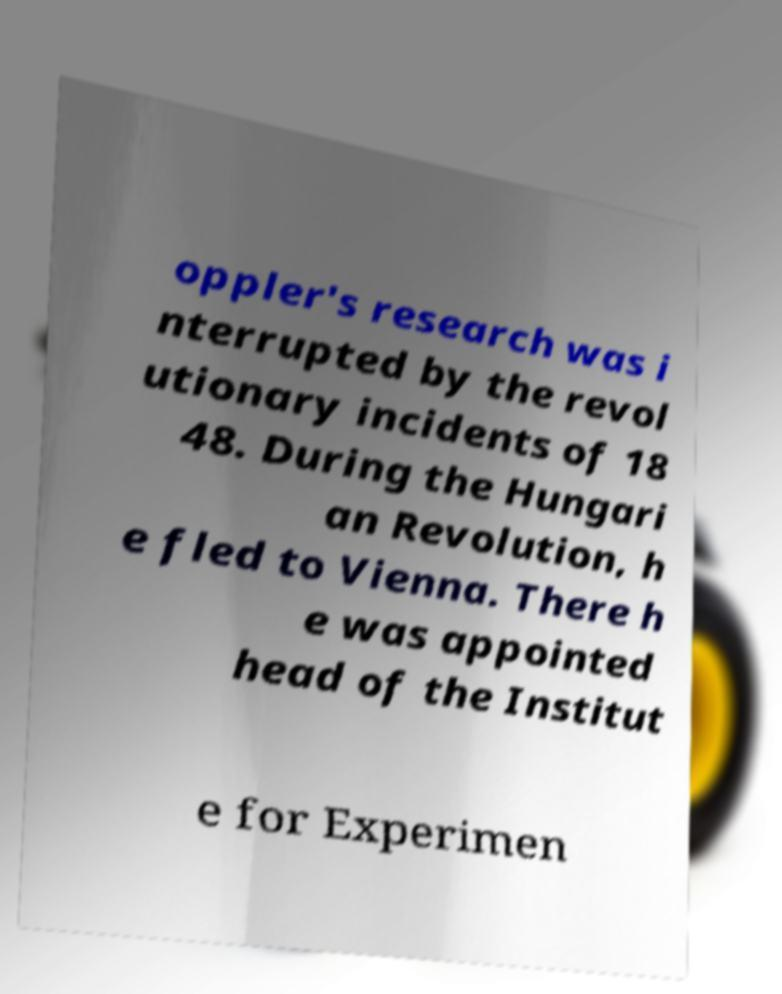What messages or text are displayed in this image? I need them in a readable, typed format. oppler's research was i nterrupted by the revol utionary incidents of 18 48. During the Hungari an Revolution, h e fled to Vienna. There h e was appointed head of the Institut e for Experimen 